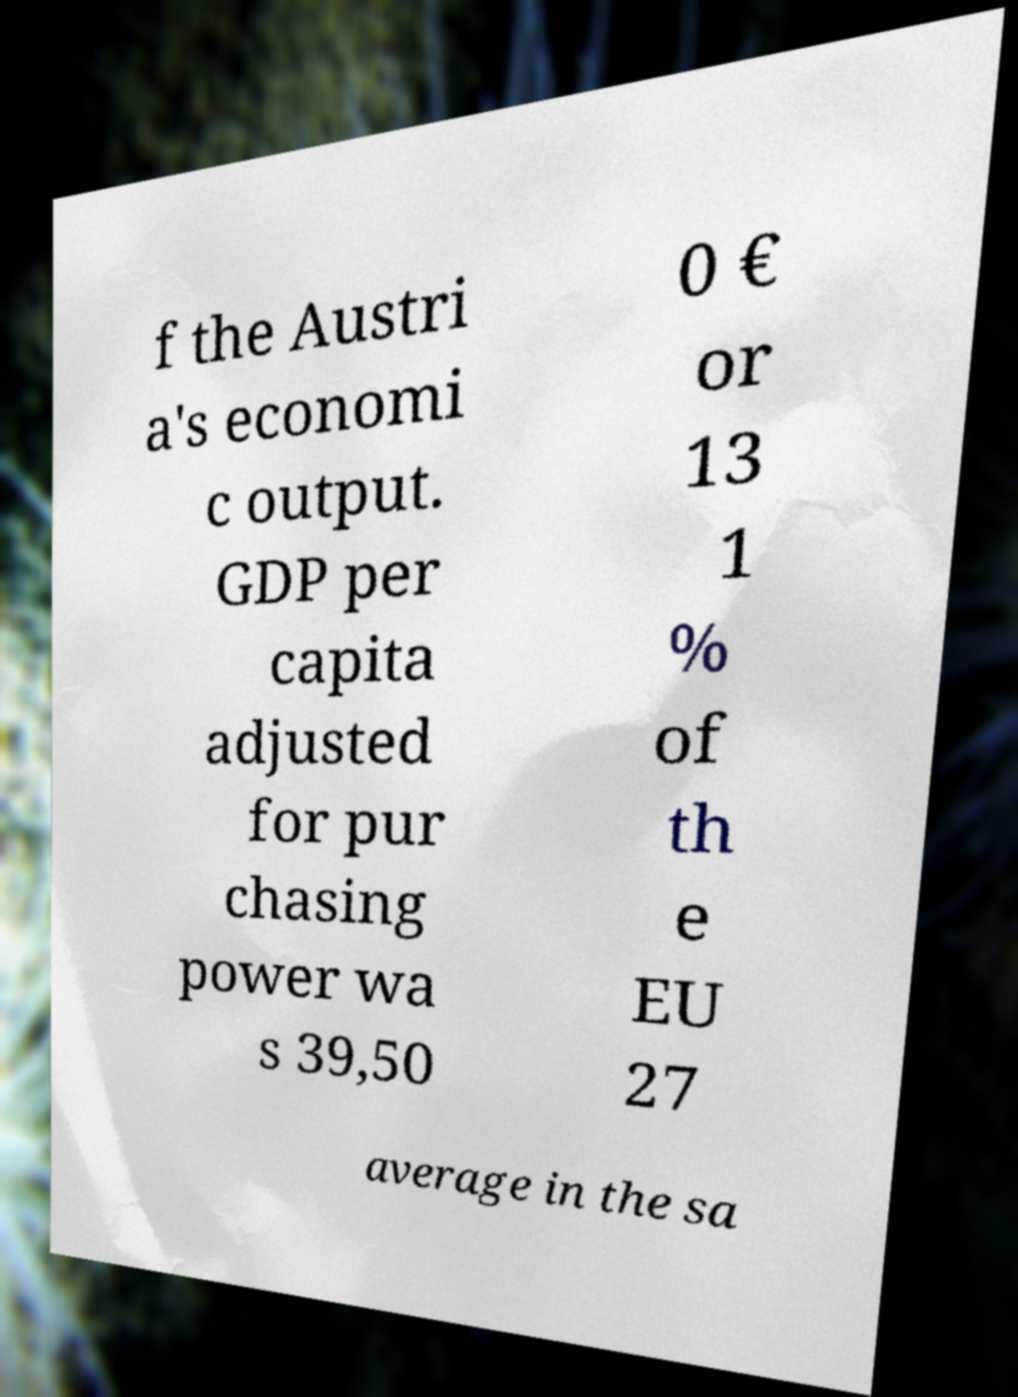For documentation purposes, I need the text within this image transcribed. Could you provide that? f the Austri a's economi c output. GDP per capita adjusted for pur chasing power wa s 39,50 0 € or 13 1 % of th e EU 27 average in the sa 